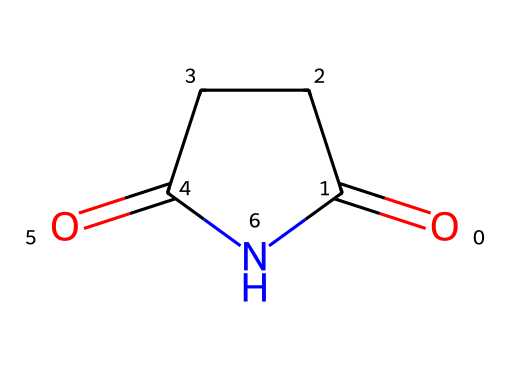What is the name of this chemical? The chemical structure given corresponds to a 5-membered cyclic imide with two carbonyl groups. This structure identifies it as succinimide.
Answer: succinimide How many carbon atoms are in succinimide? By examining the structure, there are four carbon atoms present in the molecular composition of succinimide.
Answer: four What type of functional groups does succinimide contain? The structure reveals two carbonyl (C=O) functional groups and one amine (N) group, characteristic of imides.
Answer: carbonyl and amine What is the total number of rings in succinimide? The molecular structure shows one cyclic structure which forms a single ring composed of the carbon and nitrogen atoms.
Answer: one Why is succinimide classified as an imide? Succinimide is classified as an imide because it contains a nitrogen atom bonded to two carbonyl groups, a defining feature of imides.
Answer: nitrogen bonded to carbonyls What is the molecular formula of succinimide? Examining the structure, there are four carbon atoms, five hydrogen atoms, one nitrogen atom, and two oxygen atoms, leading to the molecular formula C4H5NO2.
Answer: C4H5NO2 What physical state is succinimide likely to be found in at room temperature? Given its structure and typical properties of similar small organic molecules, succinimide is generally a solid at room temperature.
Answer: solid 